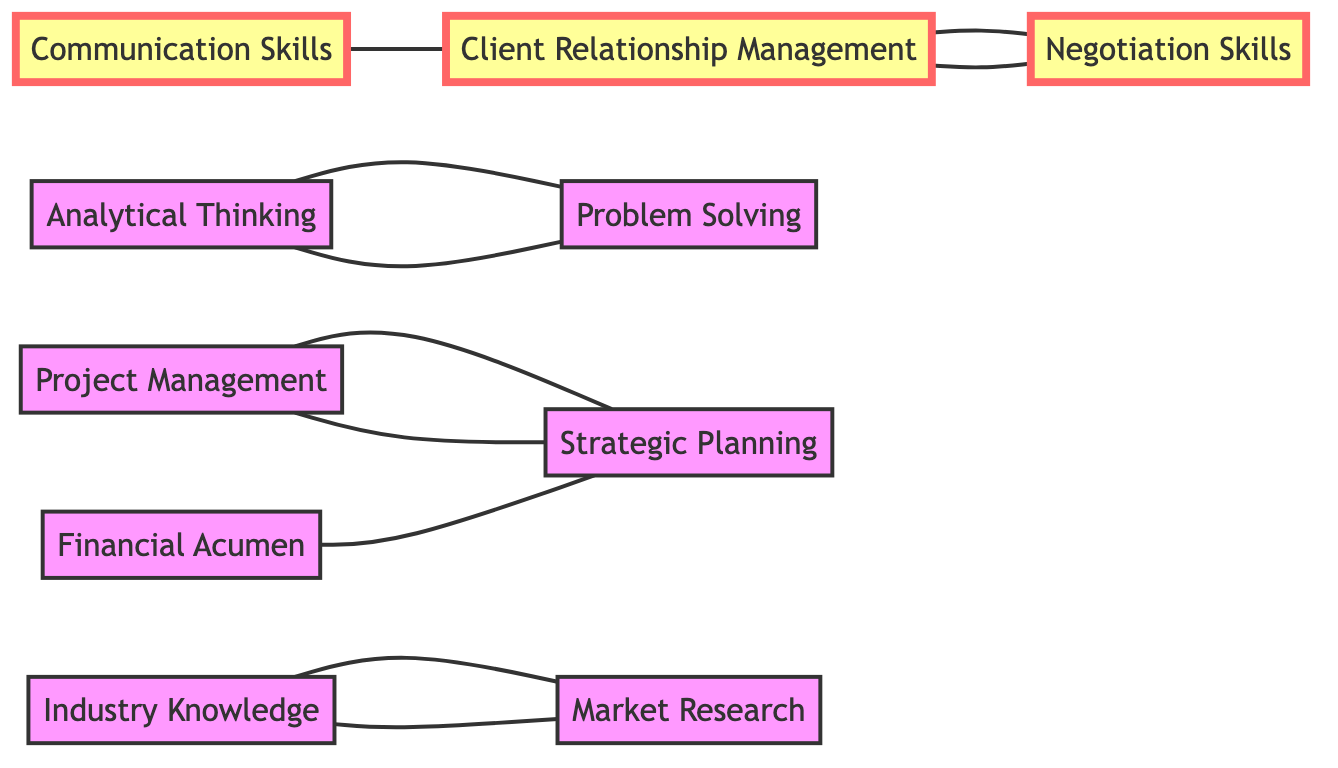What is the total number of nodes in the diagram? There are a total of 10 nodes displayed, representing different skills in the consulting industry.
Answer: 10 How many edges are connected to 'Client Relationship Management'? 'Client Relationship Management' is connected to 'Communication Skills', 'Negotiation Skills', resulting in 2 edges total.
Answer: 2 Which skill is directly connected to 'Problem Solving'? 'Problem Solving' has direct connections with 'Analytical Thinking', indicating that it complements it closely.
Answer: Analytical Thinking What are the two skills that connect 'Strategic Planning'? 'Strategic Planning' is connected to 'Project Management' and 'Financial Acumen', showing its collaboration with these skills.
Answer: Project Management, Financial Acumen Which node is a complement to 'Market Research'? 'Market Research' is complemented by 'Industry Knowledge', illustrating a direct relationship between the two.
Answer: Industry Knowledge Which skill closely relates to both 'Communication Skills' and 'Negotiation Skills'? 'Client Relationship Management' serves as a bridge connecting both 'Communication Skills' and 'Negotiation Skills'.
Answer: Client Relationship Management How many skills are directly connected to 'Financial Acumen'? 'Financial Acumen' is connected to one skill, which is 'Strategic Planning', showcasing its singular relationship.
Answer: 1 If 'Analytical Thinking' is improved, which other skill benefits directly? An improvement in 'Analytical Thinking' would directly enhance 'Problem Solving', demonstrating interrelated improvement.
Answer: Problem Solving Which skill can be considered foundational for 'Project Management'? 'Strategic Planning' acts as a foundational skill for 'Project Management', emphasizing its significance in the process.
Answer: Strategic Planning 